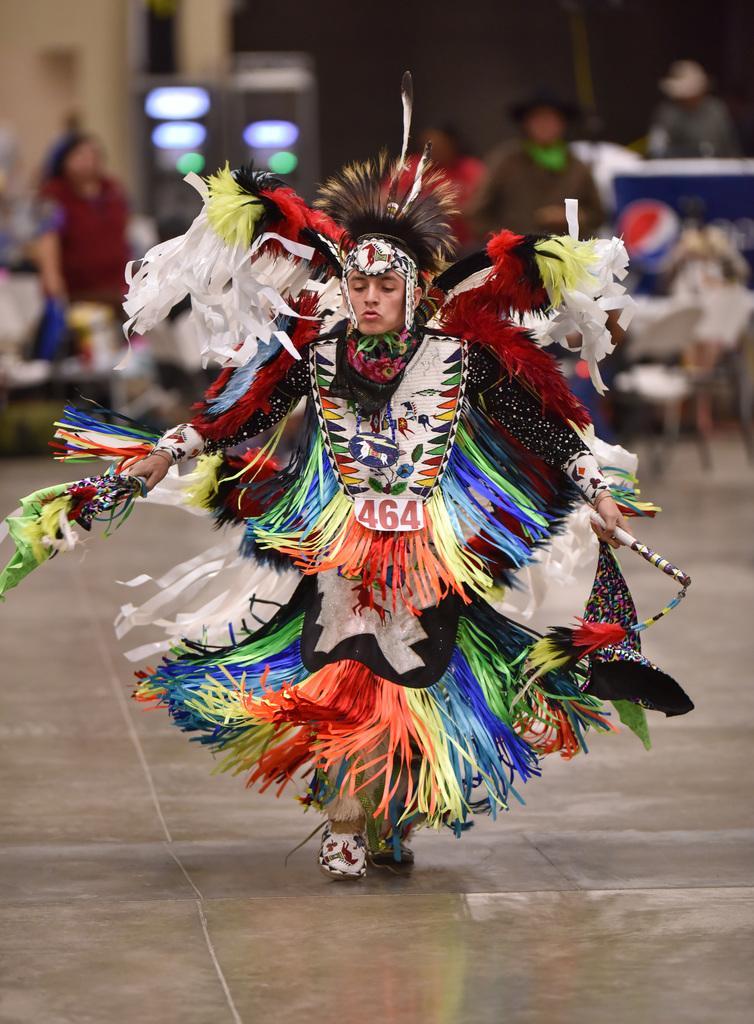Can you describe this image briefly? In this image we can see a person wearing a costume. In the background of the image there are people, chairs. At the bottom of the image there is floor. 